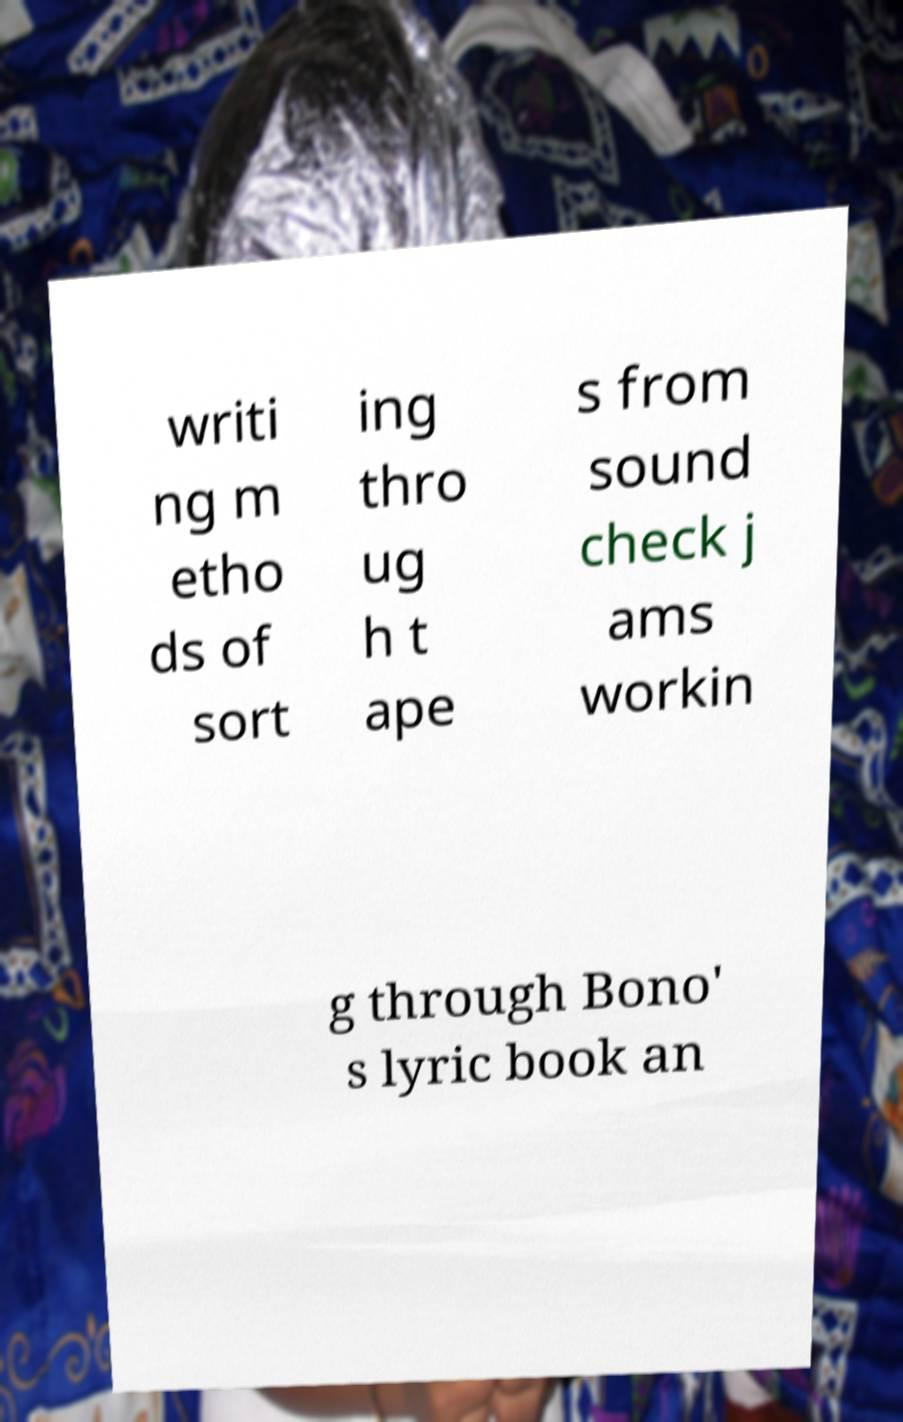Can you read and provide the text displayed in the image?This photo seems to have some interesting text. Can you extract and type it out for me? writi ng m etho ds of sort ing thro ug h t ape s from sound check j ams workin g through Bono' s lyric book an 